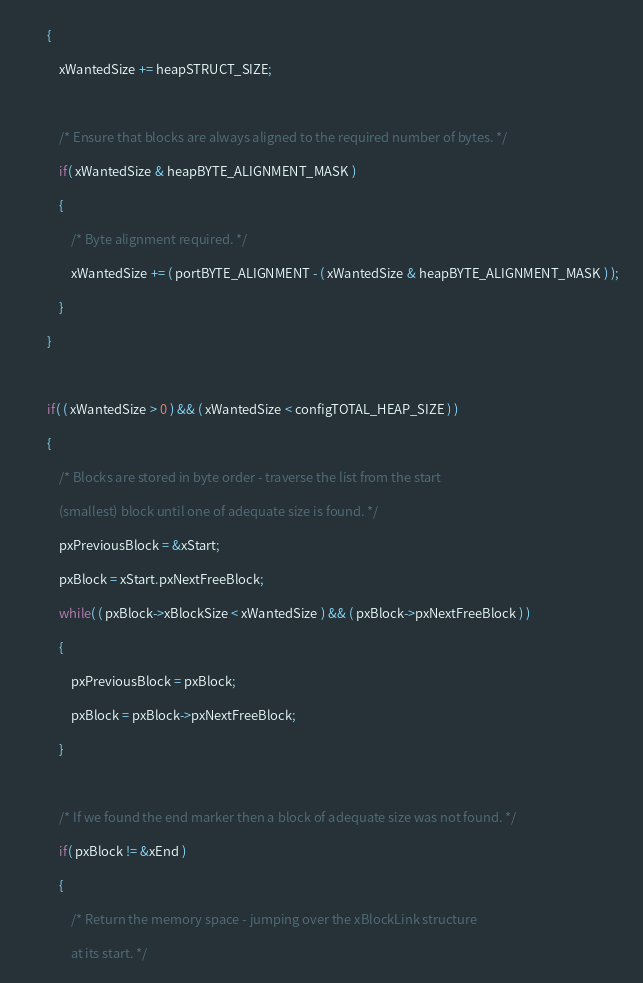<code> <loc_0><loc_0><loc_500><loc_500><_C_>		{
			xWantedSize += heapSTRUCT_SIZE;

			/* Ensure that blocks are always aligned to the required number of bytes. */
			if( xWantedSize & heapBYTE_ALIGNMENT_MASK )
			{
				/* Byte alignment required. */
				xWantedSize += ( portBYTE_ALIGNMENT - ( xWantedSize & heapBYTE_ALIGNMENT_MASK ) );
			}
		}

		if( ( xWantedSize > 0 ) && ( xWantedSize < configTOTAL_HEAP_SIZE ) )
		{
			/* Blocks are stored in byte order - traverse the list from the start
			(smallest) block until one of adequate size is found. */
			pxPreviousBlock = &xStart;
			pxBlock = xStart.pxNextFreeBlock;
			while( ( pxBlock->xBlockSize < xWantedSize ) && ( pxBlock->pxNextFreeBlock ) )
			{
				pxPreviousBlock = pxBlock;
				pxBlock = pxBlock->pxNextFreeBlock;
			}

			/* If we found the end marker then a block of adequate size was not found. */
			if( pxBlock != &xEnd )
			{
				/* Return the memory space - jumping over the xBlockLink structure
				at its start. */</code> 